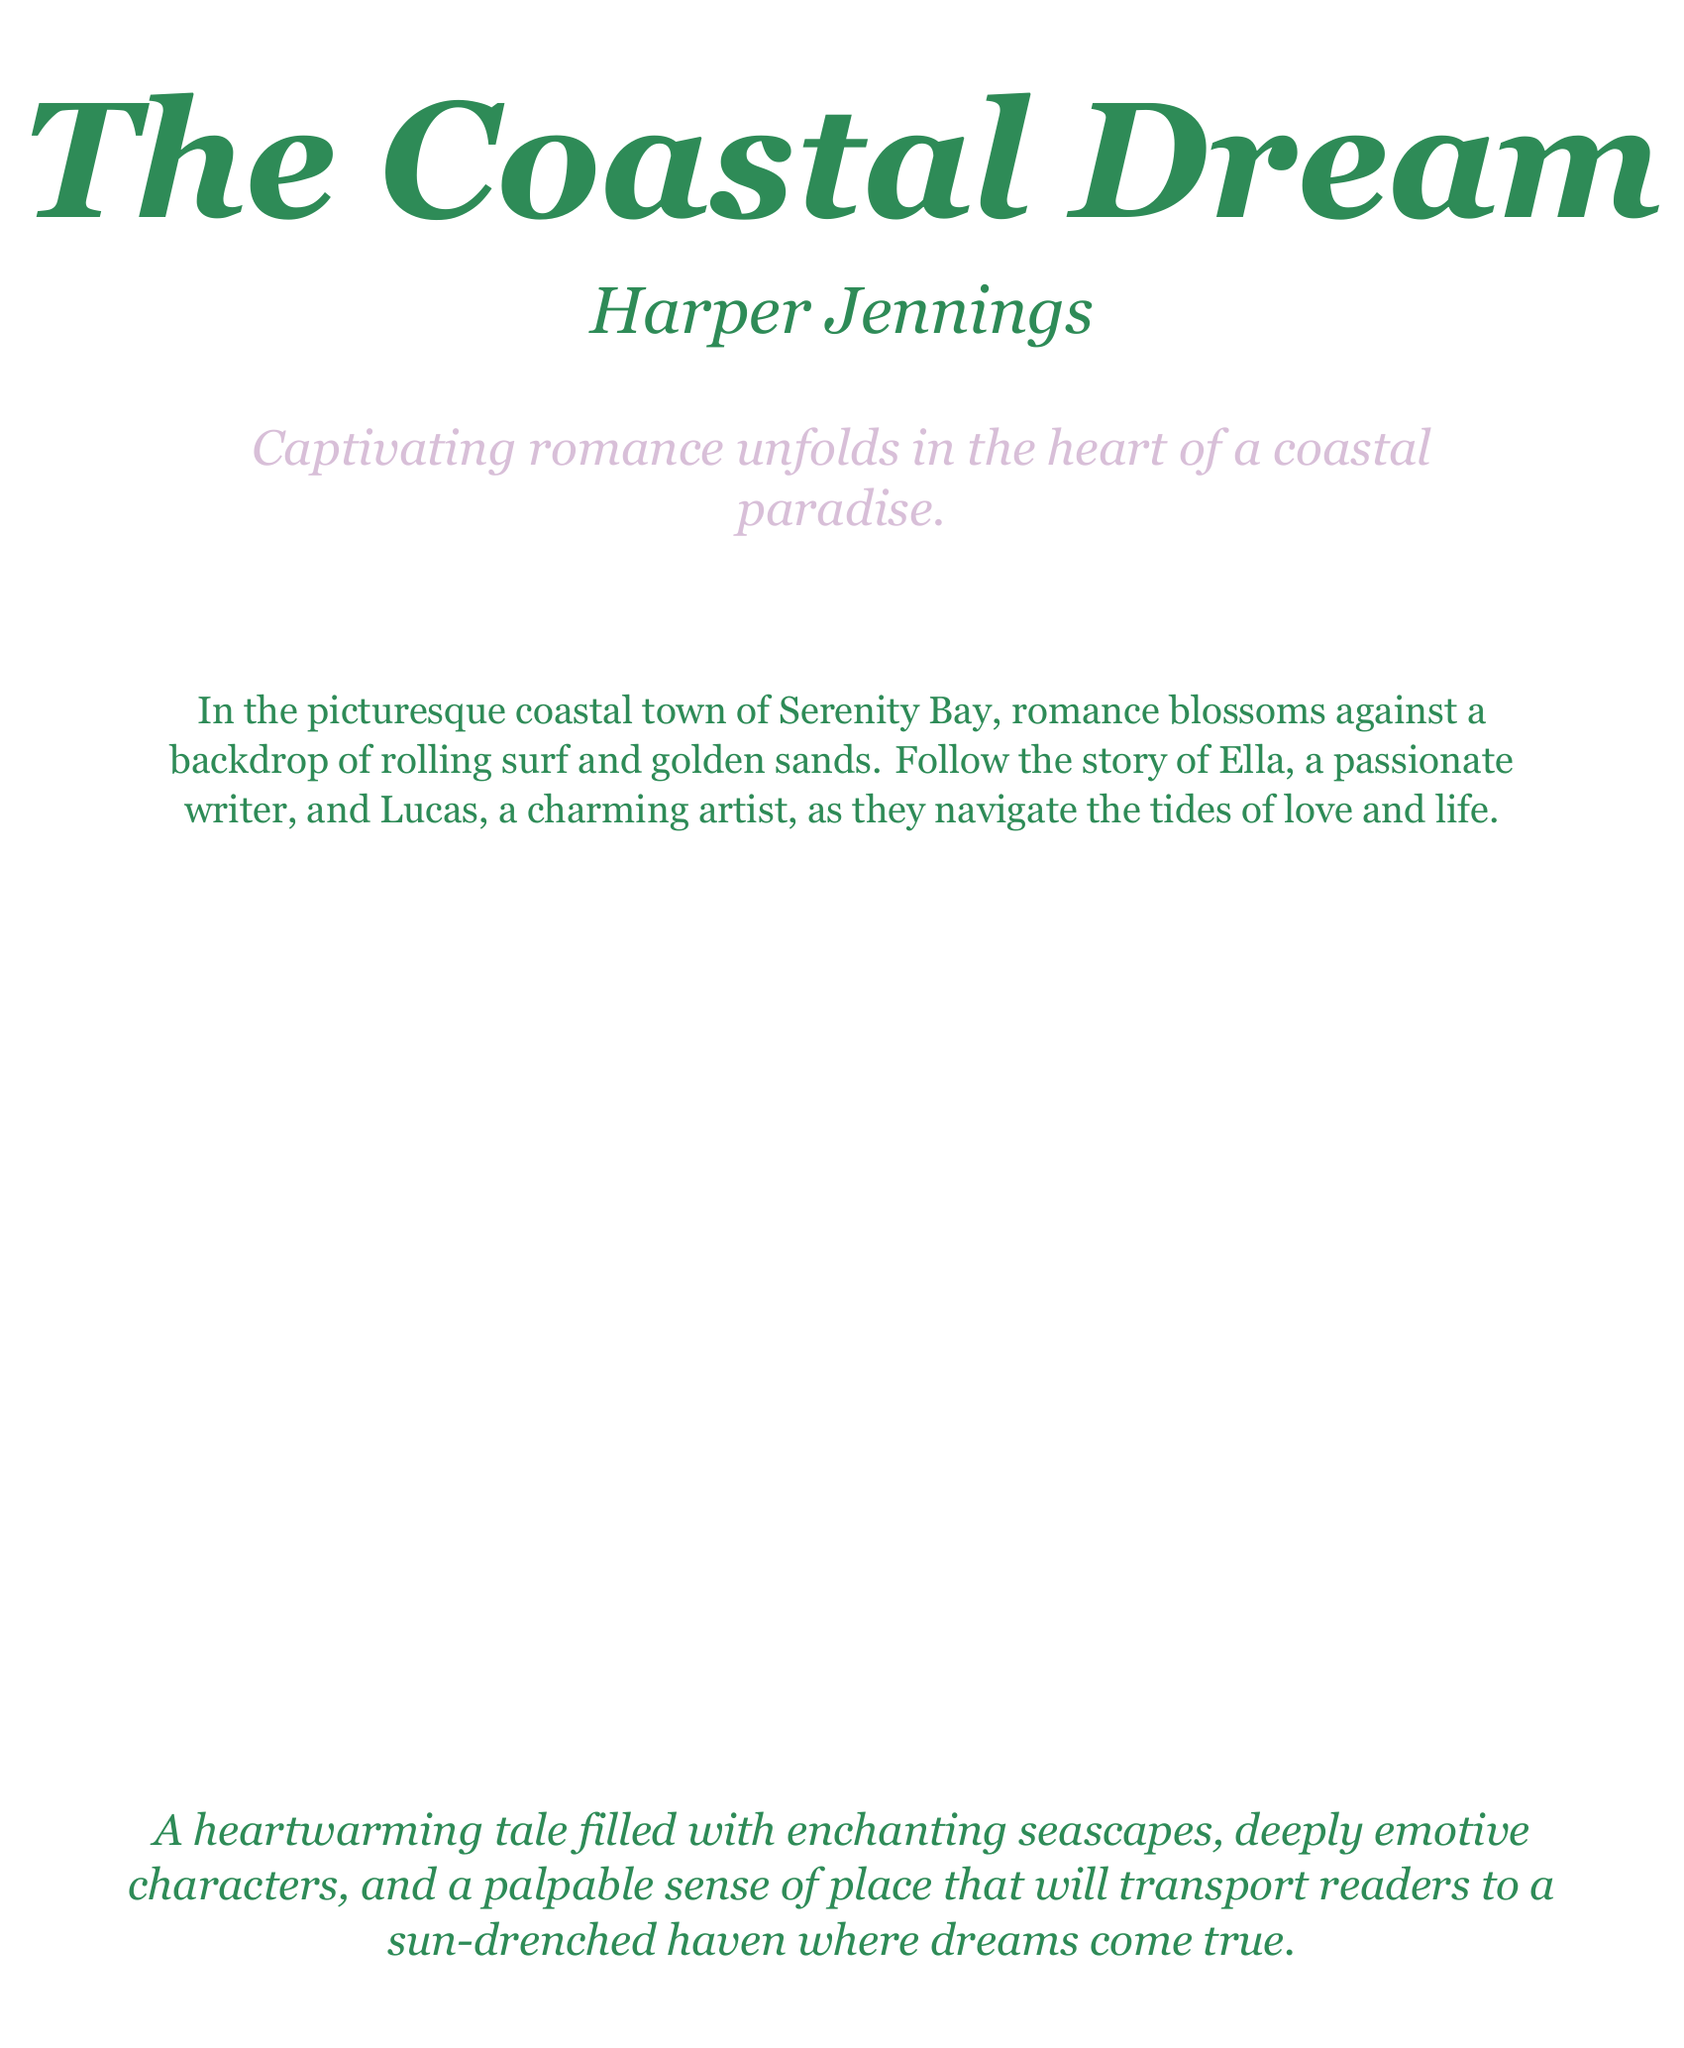What is the title of the book? The title of the book is prominently displayed on the cover in large font.
Answer: The Coastal Dream Who is the author? The author's name is given beneath the title.
Answer: Harper Jennings What town is the story set in? The setting of the romance novel is mentioned in the book description.
Answer: Serenity Bay What two main characters are introduced in the summary? The summary names the central characters involved in the romance.
Answer: Ella and Lucas What genre does the book belong to? The document indicates the type of story being told.
Answer: Romance What emotions are the characters likely to experience according to the cover? The description hints at the emotional journey the characters embark on.
Answer: Deeply emotive What is the main theme of the book? The book cover describes a key aspect of the narrative.
Answer: Romance What atmosphere does the author aim to create according to the cover? The text suggests the overall feeling and setting described in the book.
Answer: Sun-drenched haven 